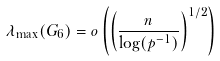Convert formula to latex. <formula><loc_0><loc_0><loc_500><loc_500>\lambda _ { \max } ( G _ { 6 } ) = o \left ( \left ( \frac { n } { \log ( p ^ { - 1 } ) } \right ) ^ { 1 / 2 } \right )</formula> 